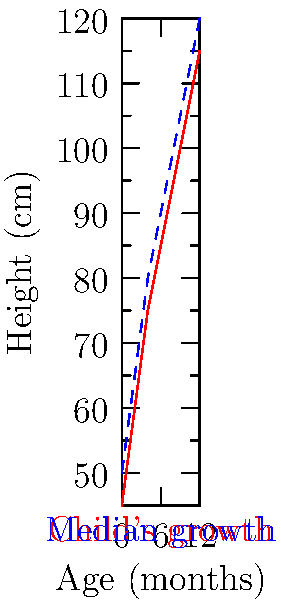Based on the growth chart shown, which best describes the growth pattern of the child in comparison to the median growth for children in Equatorial Guinea? To interpret this growth chart, we need to follow these steps:

1. Identify the lines: The red solid line represents the child's growth, while the blue dashed line represents the median growth for children in Equatorial Guinea.

2. Compare the lines: We can see that the child's growth line (red) is consistently below the median growth line (blue).

3. Analyze the trend: The child's growth line follows a similar pattern to the median, but it remains below it throughout the age range shown (0-12 months).

4. Quantify the difference: The gap between the child's growth and the median appears to be relatively constant, about 5-10 cm below the median at each age point.

5. Consider local context: As a health professional in Equatorial Guinea, it's important to remember that local factors such as genetics, nutrition, and environmental conditions can influence growth patterns.

6. Conclusion: The child is growing at a rate parallel to but consistently below the median for children in Equatorial Guinea. This pattern suggests that the child is smaller than average but maintaining a consistent growth rate.
Answer: Consistent growth below median 